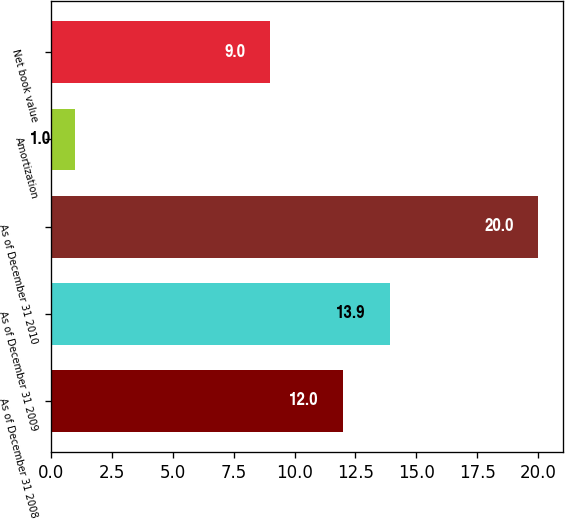Convert chart to OTSL. <chart><loc_0><loc_0><loc_500><loc_500><bar_chart><fcel>As of December 31 2008<fcel>As of December 31 2009<fcel>As of December 31 2010<fcel>Amortization<fcel>Net book value<nl><fcel>12<fcel>13.9<fcel>20<fcel>1<fcel>9<nl></chart> 